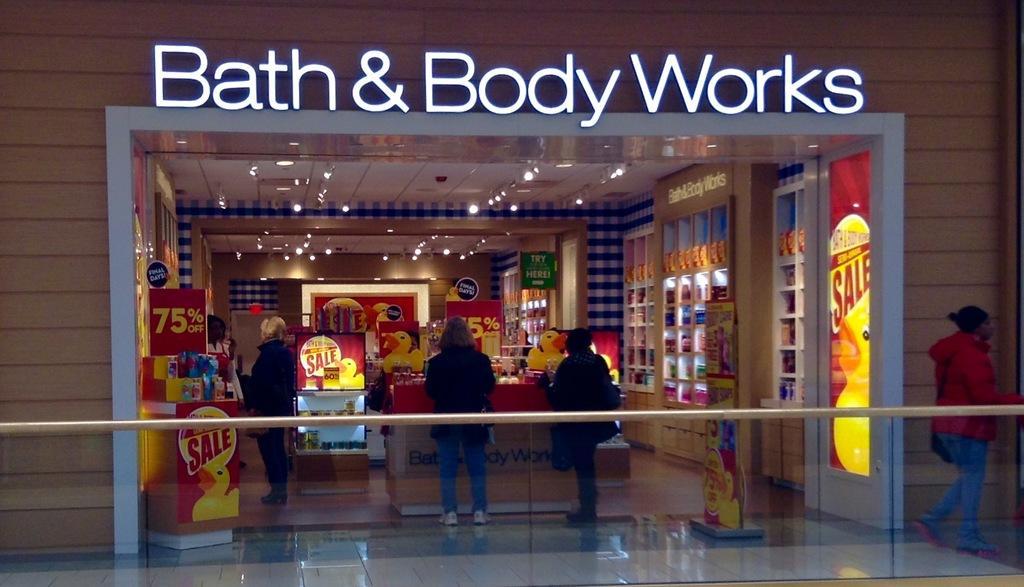How would you summarize this image in a sentence or two? In this image we can see a shop were three people are standing. Right side of the image one lady is walking, she is wearing red jacket with jeans. 